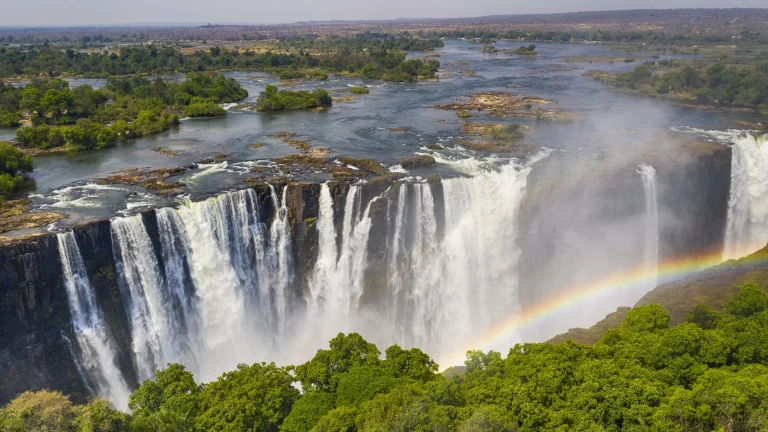Describe the following image. This breathtaking image captures a panoramic view of Victoria Falls, one of the largest and most magnificent waterfalls in the world. Positioned on the border between Zambia and Zimbabwe, the falls dominate the landscape with their immense power and beauty. The aerial perspective showcases the Zambezi River as it dramatically plunges over the edge, creating a series of cascading torrents that disappear into a churning mist below. The dense mist rises and envelopes the base of the falls, sometimes forming a heavy curtain that obscures the view of the bottom, creating a mysterious and awe-inspiring atmosphere. Brilliantly, a rainbow arches gracefully through the mist, adding a vibrant array of colors to the scene. Surrounding the falls, lush, verdant vegetation thrives, offering a stark contrast to the raw power of the water. This mesmerizing image not only highlights the physical grandeur of Victoria Falls but also gives a sense of the rich ecosystem supported by this natural wonder. 